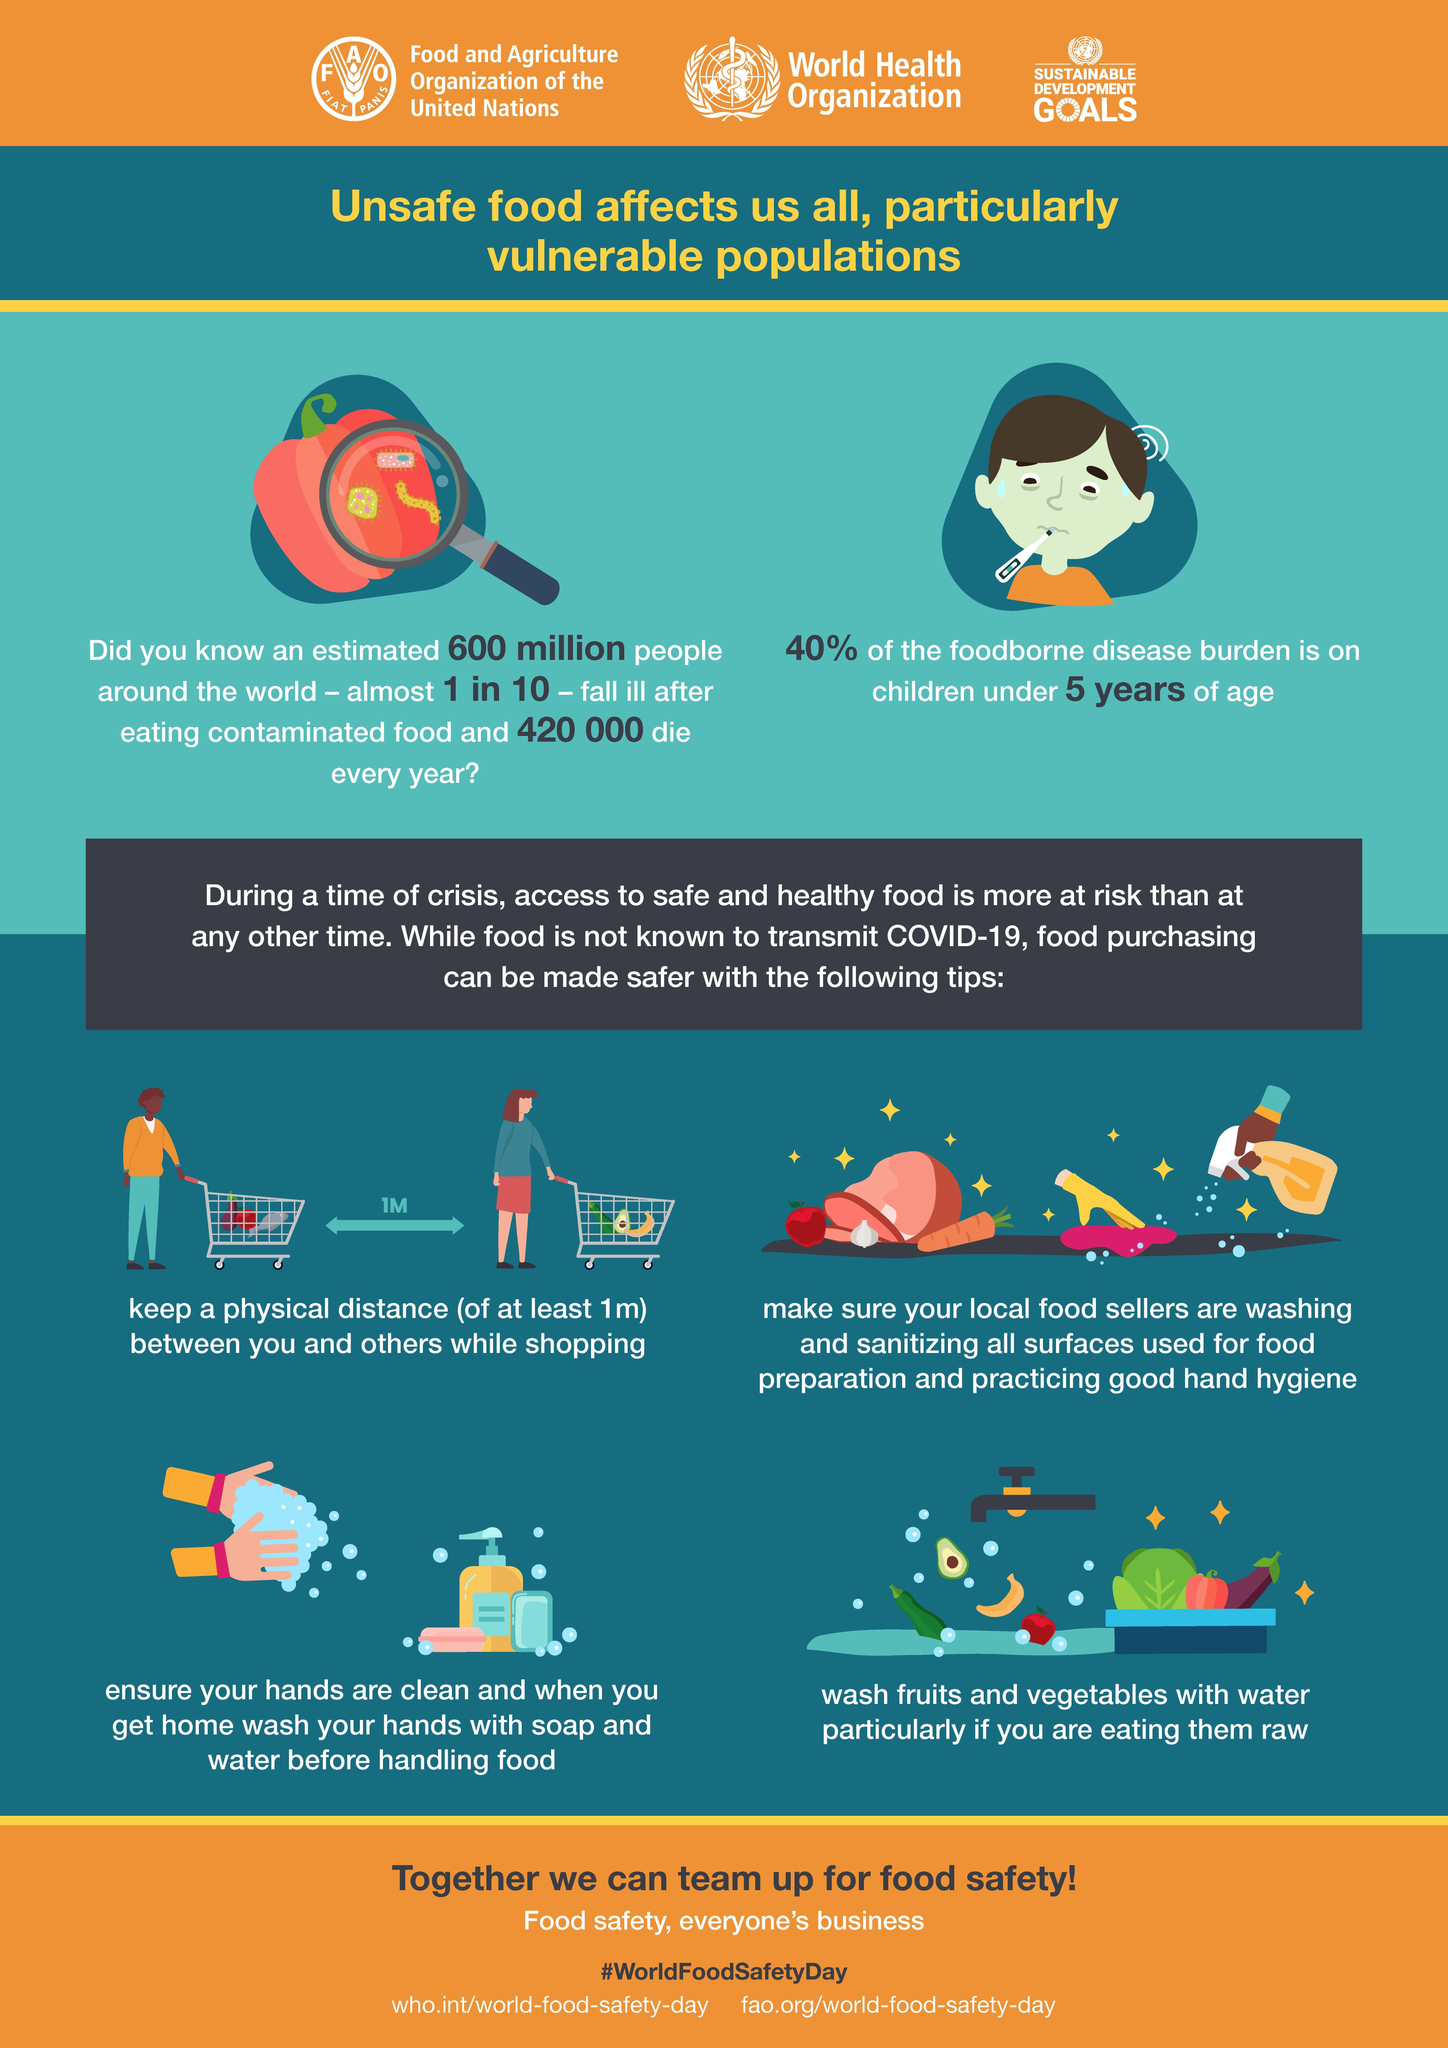How many get sick from unsafe food each year worldwide?
Answer the question with a short phrase. an estimated 600 million How should you handle foods that might be eaten raw? wash fruits and vegetables with water What is the proportion of people who are affected by consumption of contaminated food each year? 1 in 10 What is the estimated number of fatalities due to consumption of unsafe food each year? 420 000 Which age group is likely to be the most vulnerable to foodborne diseases? children under 5 years of age As per the infographic, what safety measure should be taken while shopping? keep a physical distance (of at least 1m) between you and others What measure is to be taken before handling food? wash your hands with soap and water 